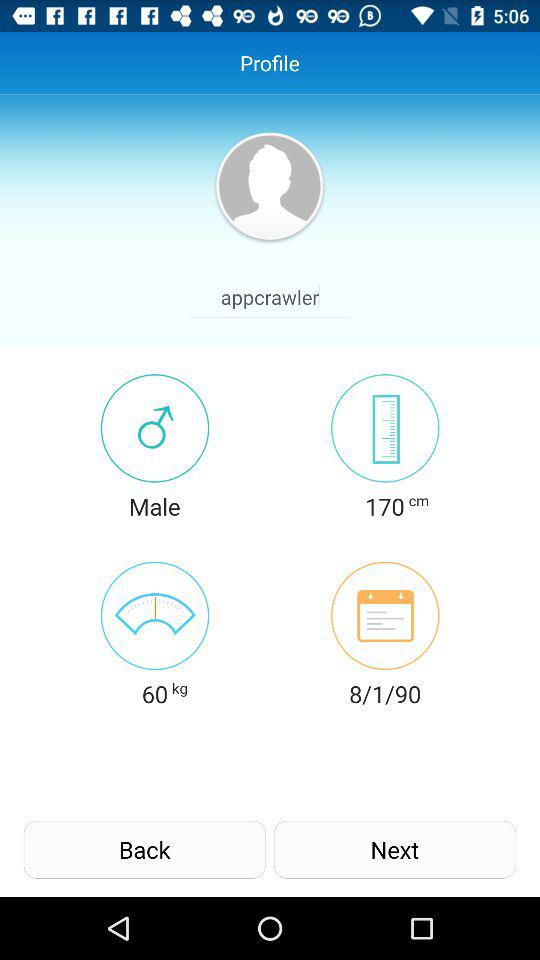What is the weight? The weight is 60 kg. 